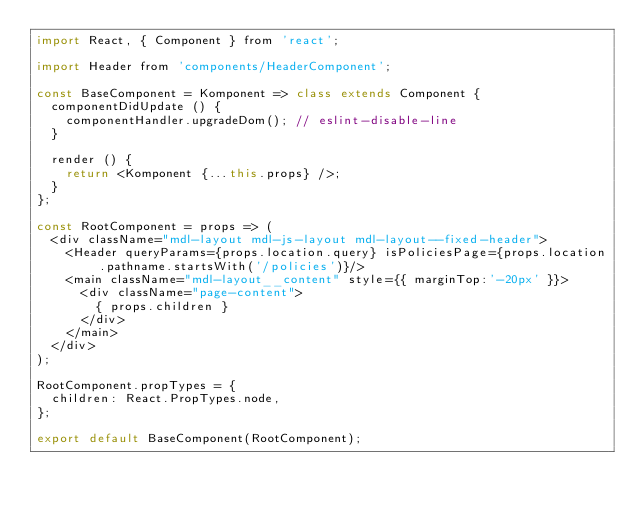Convert code to text. <code><loc_0><loc_0><loc_500><loc_500><_JavaScript_>import React, { Component } from 'react';

import Header from 'components/HeaderComponent';

const BaseComponent = Komponent => class extends Component {
  componentDidUpdate () {
    componentHandler.upgradeDom(); // eslint-disable-line
  }

  render () {
    return <Komponent {...this.props} />;
  }
};

const RootComponent = props => (
  <div className="mdl-layout mdl-js-layout mdl-layout--fixed-header">
    <Header queryParams={props.location.query} isPoliciesPage={props.location.pathname.startsWith('/policies')}/>
    <main className="mdl-layout__content" style={{ marginTop:'-20px' }}>
      <div className="page-content">
        { props.children }
      </div>
    </main>
  </div>
);

RootComponent.propTypes = {
  children: React.PropTypes.node,
};

export default BaseComponent(RootComponent);
</code> 